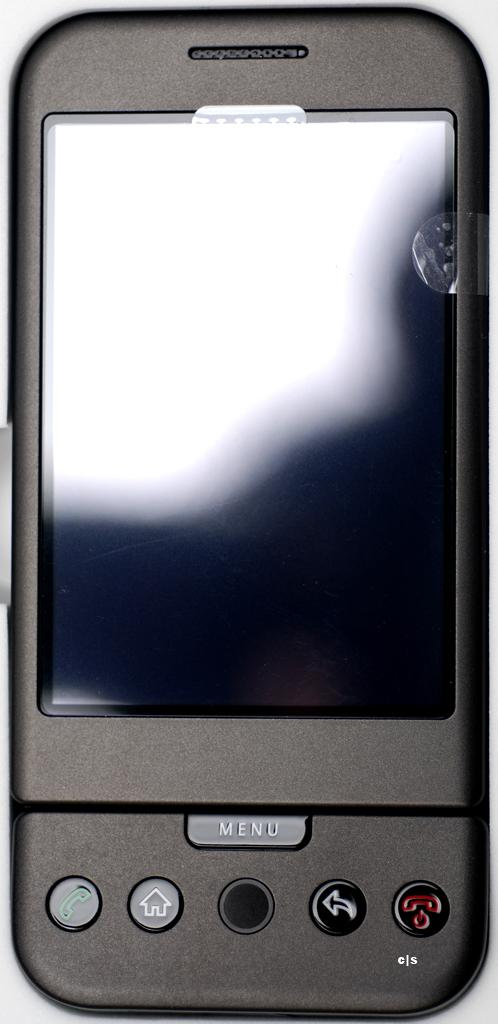<image>
Create a compact narrative representing the image presented. the name menu is on the black phone with the reflection 